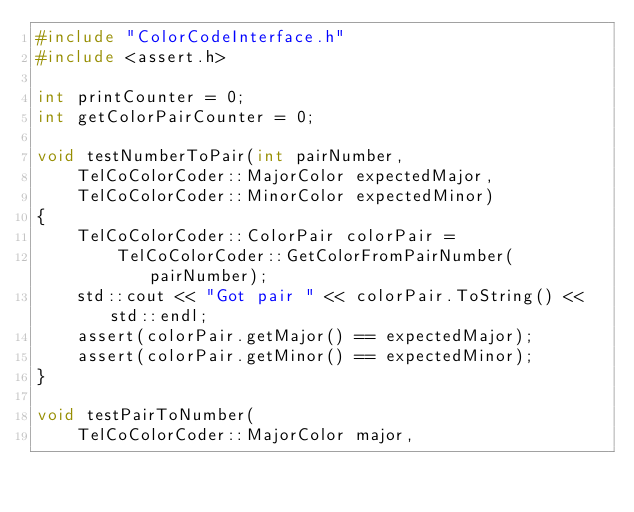<code> <loc_0><loc_0><loc_500><loc_500><_C_>#include "ColorCodeInterface.h"
#include <assert.h>

int printCounter = 0;
int getColorPairCounter = 0;

void testNumberToPair(int pairNumber,
    TelCoColorCoder::MajorColor expectedMajor,
    TelCoColorCoder::MinorColor expectedMinor)
{
    TelCoColorCoder::ColorPair colorPair =
        TelCoColorCoder::GetColorFromPairNumber(pairNumber);
    std::cout << "Got pair " << colorPair.ToString() << std::endl;
    assert(colorPair.getMajor() == expectedMajor);
    assert(colorPair.getMinor() == expectedMinor);
}

void testPairToNumber(
    TelCoColorCoder::MajorColor major,</code> 